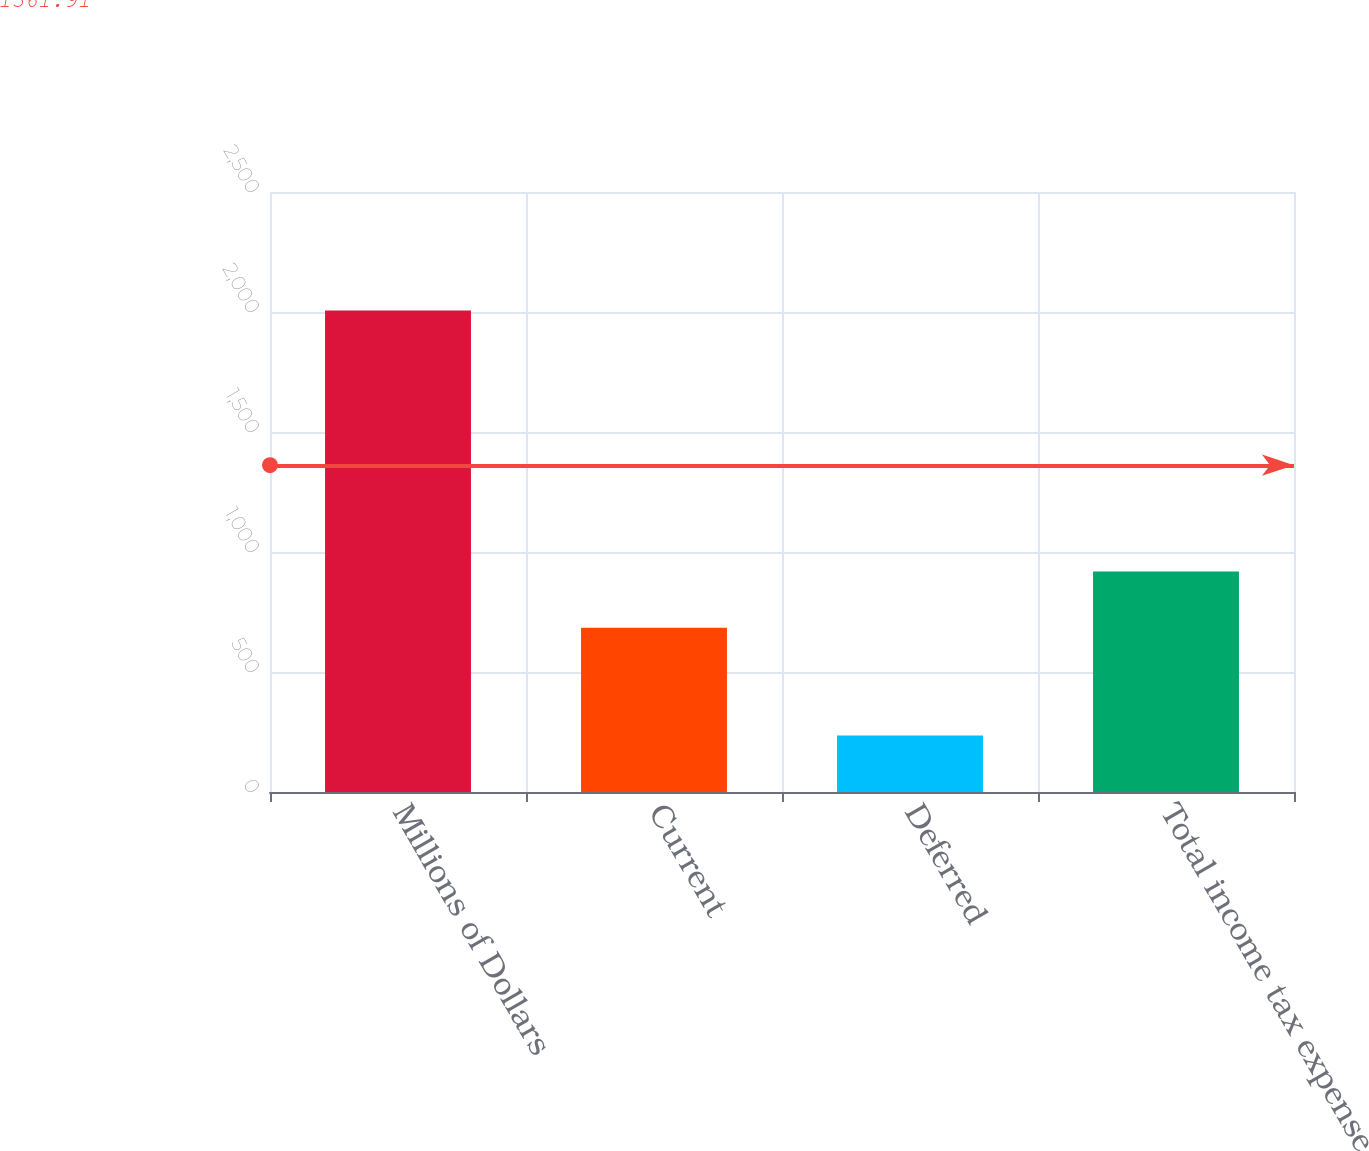Convert chart. <chart><loc_0><loc_0><loc_500><loc_500><bar_chart><fcel>Millions of Dollars<fcel>Current<fcel>Deferred<fcel>Total income tax expense<nl><fcel>2006<fcel>684<fcel>235<fcel>919<nl></chart> 